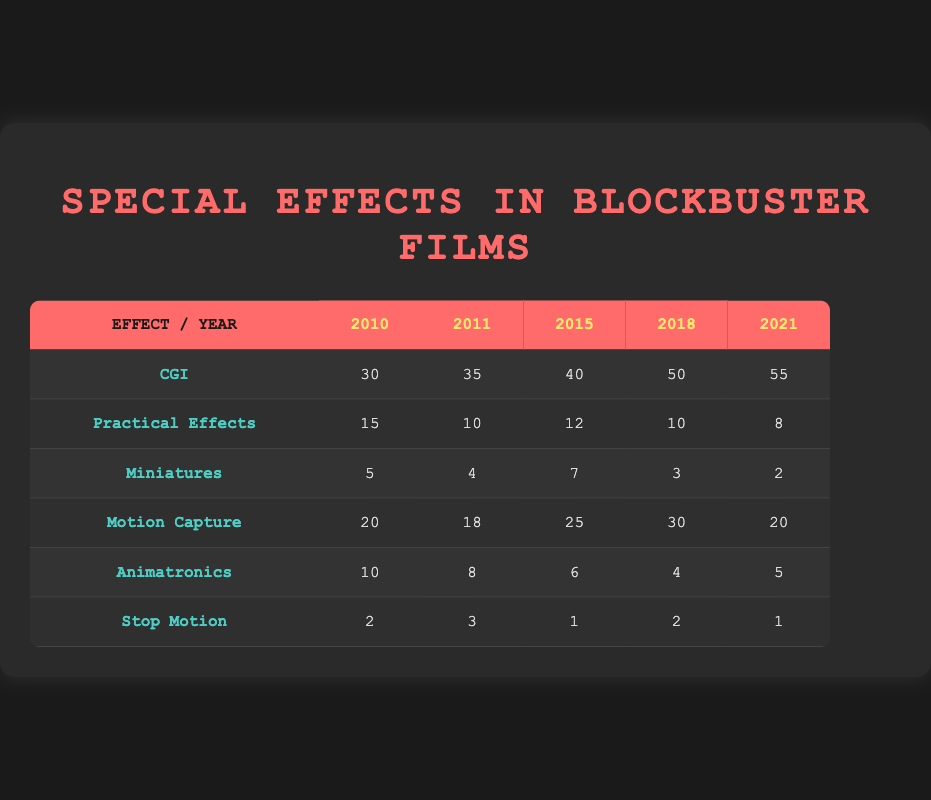What was the highest usage of CGI techniques and in which year? The highest usage of CGI techniques is 55 in the year 2021, which can be directly observed in the row corresponding to CGI under the year 2021.
Answer: 55 in 2021 How many Practical Effects were used in total from 2010 to 2021? Adding the values of Practical Effects from each year: 15 (2010) + 10 (2011) + 12 (2015) + 10 (2018) + 8 (2021) = 55.
Answer: 55 Is the usage of Miniatures consistent over the years? Analyzing the values: 5 (2010), 4 (2011), 7 (2015), 3 (2018), 2 (2021) shows that the numbers fluctuate and there is no consistent trend. The values decrease after 2015.
Answer: No What type of special effect had the lowest usage in 2018? In 2018, Stop Motion had the lowest usage with a count of 2. This is found in the row for Stop Motion under the year 2018.
Answer: Stop Motion What is the difference in the usage of Motion Capture between 2015 and 2021? The usage of Motion Capture in 2015 is 25 and in 2021 is 20. The difference is calculated as 25 - 20 = 5.
Answer: 5 In which year did the usage of Practical Effects drop below 10? The values for Practical Effects are 15 (2010), 10 (2011), 12 (2015), 10 (2018), 8 (2021). The first year where it drops below 10 is 2021.
Answer: 2021 Which special effect technique had a consistent downward trend from 2010 to 2021? Evaluating the data, Practical Effects: 15, 10, 12, 10, 8 shows a downward trend; Miniatures: 5, 4, 7, 3, 2 also shows a decrease. The strongest downward trend is seen in Practical Effects.
Answer: Practical Effects What was the total count of Stop Motion techniques employed from 2010 to 2021? Summing the values for Stop Motion gives 2 (2010) + 3 (2011) + 1 (2015) + 2 (2018) + 1 (2021) = 9.
Answer: 9 